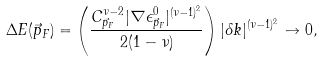Convert formula to latex. <formula><loc_0><loc_0><loc_500><loc_500>\Delta E ( \vec { p } _ { F } ) = \left ( \frac { C _ { \vec { p } _ { F } } ^ { \nu - 2 } | \nabla \epsilon ^ { 0 } _ { \vec { p } _ { F } } | ^ { ( \nu - 1 ) ^ { 2 } } } { 2 ( 1 - \nu ) } \right ) | \delta k | ^ { ( \nu - 1 ) ^ { 2 } } \to 0 ,</formula> 